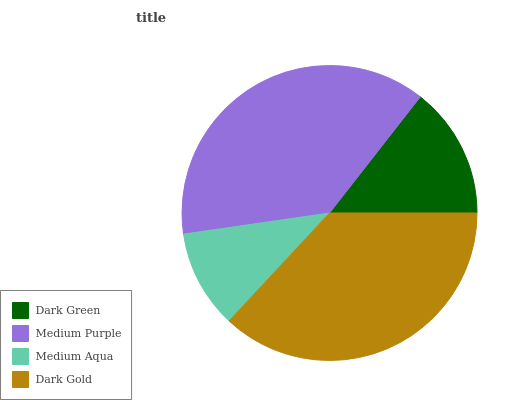Is Medium Aqua the minimum?
Answer yes or no. Yes. Is Medium Purple the maximum?
Answer yes or no. Yes. Is Medium Purple the minimum?
Answer yes or no. No. Is Medium Aqua the maximum?
Answer yes or no. No. Is Medium Purple greater than Medium Aqua?
Answer yes or no. Yes. Is Medium Aqua less than Medium Purple?
Answer yes or no. Yes. Is Medium Aqua greater than Medium Purple?
Answer yes or no. No. Is Medium Purple less than Medium Aqua?
Answer yes or no. No. Is Dark Gold the high median?
Answer yes or no. Yes. Is Dark Green the low median?
Answer yes or no. Yes. Is Dark Green the high median?
Answer yes or no. No. Is Dark Gold the low median?
Answer yes or no. No. 